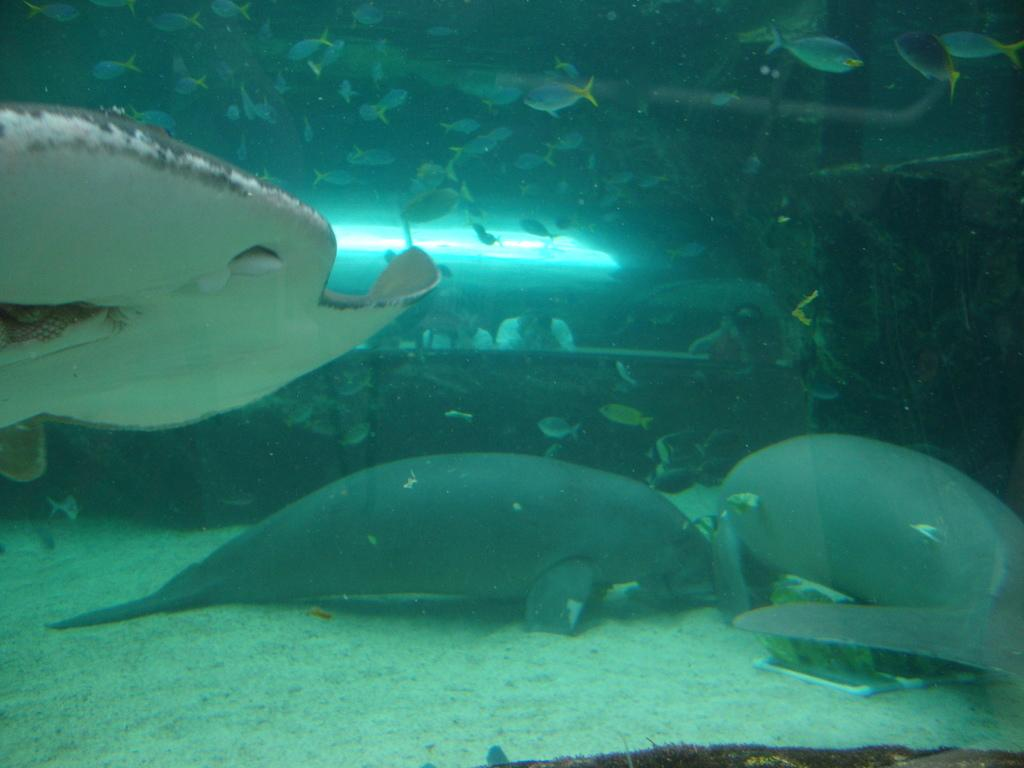What type of animals can be seen in the image? There are aquatic animals in the image. What is the primary element visible in the background of the image? There is water visible in the background of the image. What is present at the bottom of the image? There is soil at the bottom of the image. What type of mountain can be seen in the image? There is no mountain present in the image. Is there a church visible in the image? There is no church present in the image. 